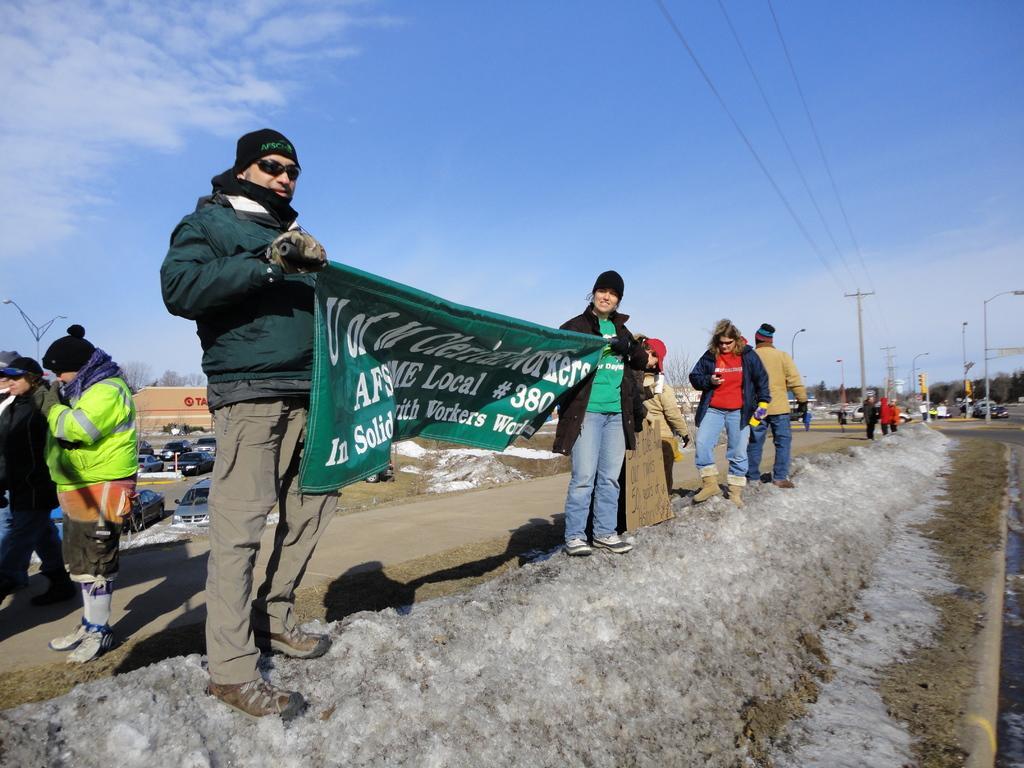Please provide a concise description of this image. In this image I can see some snow on the ground, few person wearing jackets are standing and holding a green colored banner, few vehicles on the ground, few poles, few wires, few lights, the road, few vehicles on the road, few trees, few buildings and in the background I can see the sky. 